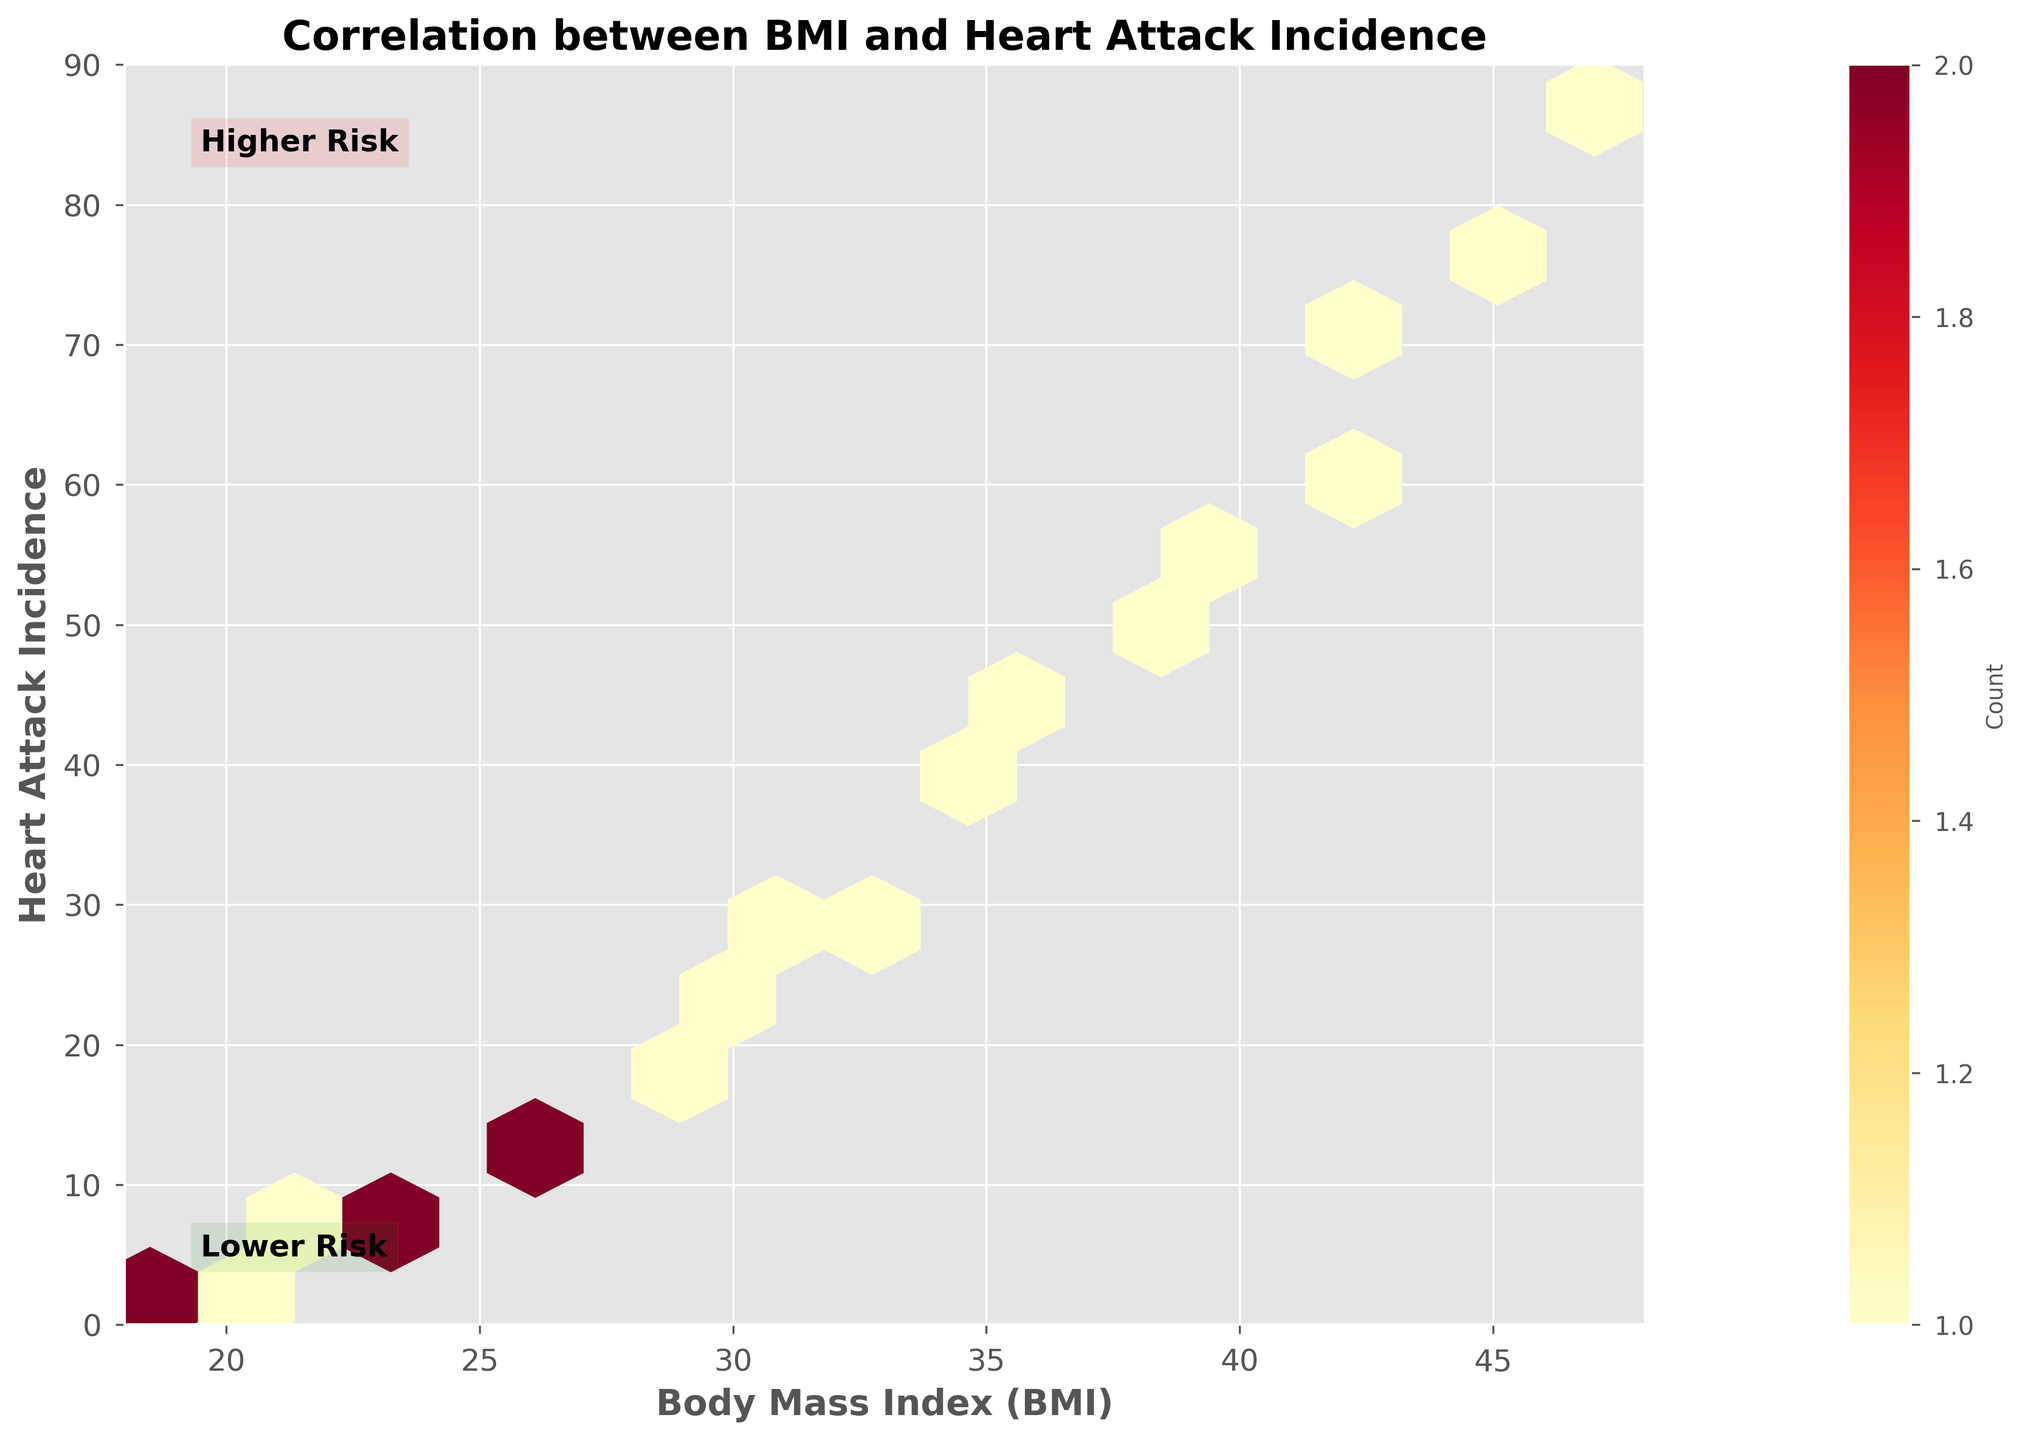What is the title of the hexbin plot? The title is located at the top center of the figure and is usually in a larger bold font to indicate the main topic of the plot.
Answer: Correlation between BMI and Heart Attack Incidence What does the color intensity represent in the plot? The color intensity in a hexbin plot represents the count of data points within each hexagon. Darker colors indicate higher counts.
Answer: Count of data points What are the ranges of BMI and Heart Attack Incidence shown in the plot? The ranges are indicated by the x-axis and y-axis limits. The x-axis and y-axis labels depict the minimum and maximum values for BMI and Heart Attack Incidence respectively.
Answer: BMI: 18-48, Heart Attack Incidence: 0-90 Which BMI range has the highest count of heart attack incidences? By observing the darkest hexagons, we can determine which BMI range clusters the most data points, indicating the highest count.
Answer: Around BMI 37-43 How many BMI intervals are there along the x-axis of the plot? The number of tick marks along the x-axis can provide the number of BMI intervals shown in the plot.
Answer: Eight (8) Does a higher BMI generally correlate with a higher incidence of heart attacks based on the plot? By looking at the general trend and distribution of hexagon colors moving from left to right, we can observe whether higher BMI values are associated with more heart attack incidences.
Answer: Yes What can you infer about the heart attack incidence for a BMI of around 22? By finding the hexagon that represents a BMI of around 22 and checking its color intensity, we can estimate the heart attack incidence.
Answer: Approximately 7 heart attacks Which BMI value corresponds to the highest observed heart attack incidence in the plot? Finding the maximum y-value of the plotted hexagons and corresponding it to the x-value (BMI) can help locate this.
Answer: BMI around 47 Is there a clear boundary that distinguishes "Lower Risk" and "Higher Risk"? By observing the annotations and the distribution of hexagon colors, we can determine if there is a sharp distinction between lower and higher risk zones.
Answer: No clear boundary, but general trend Between BMI values of 30 and 35, what is the approximate range of heart attack incidences? By examining the hexagons within the BMI range of 30-35 and noting the heart attack incidence values on the y-axis, we can find the range.
Answer: Approximately 26-36 heart attacks 